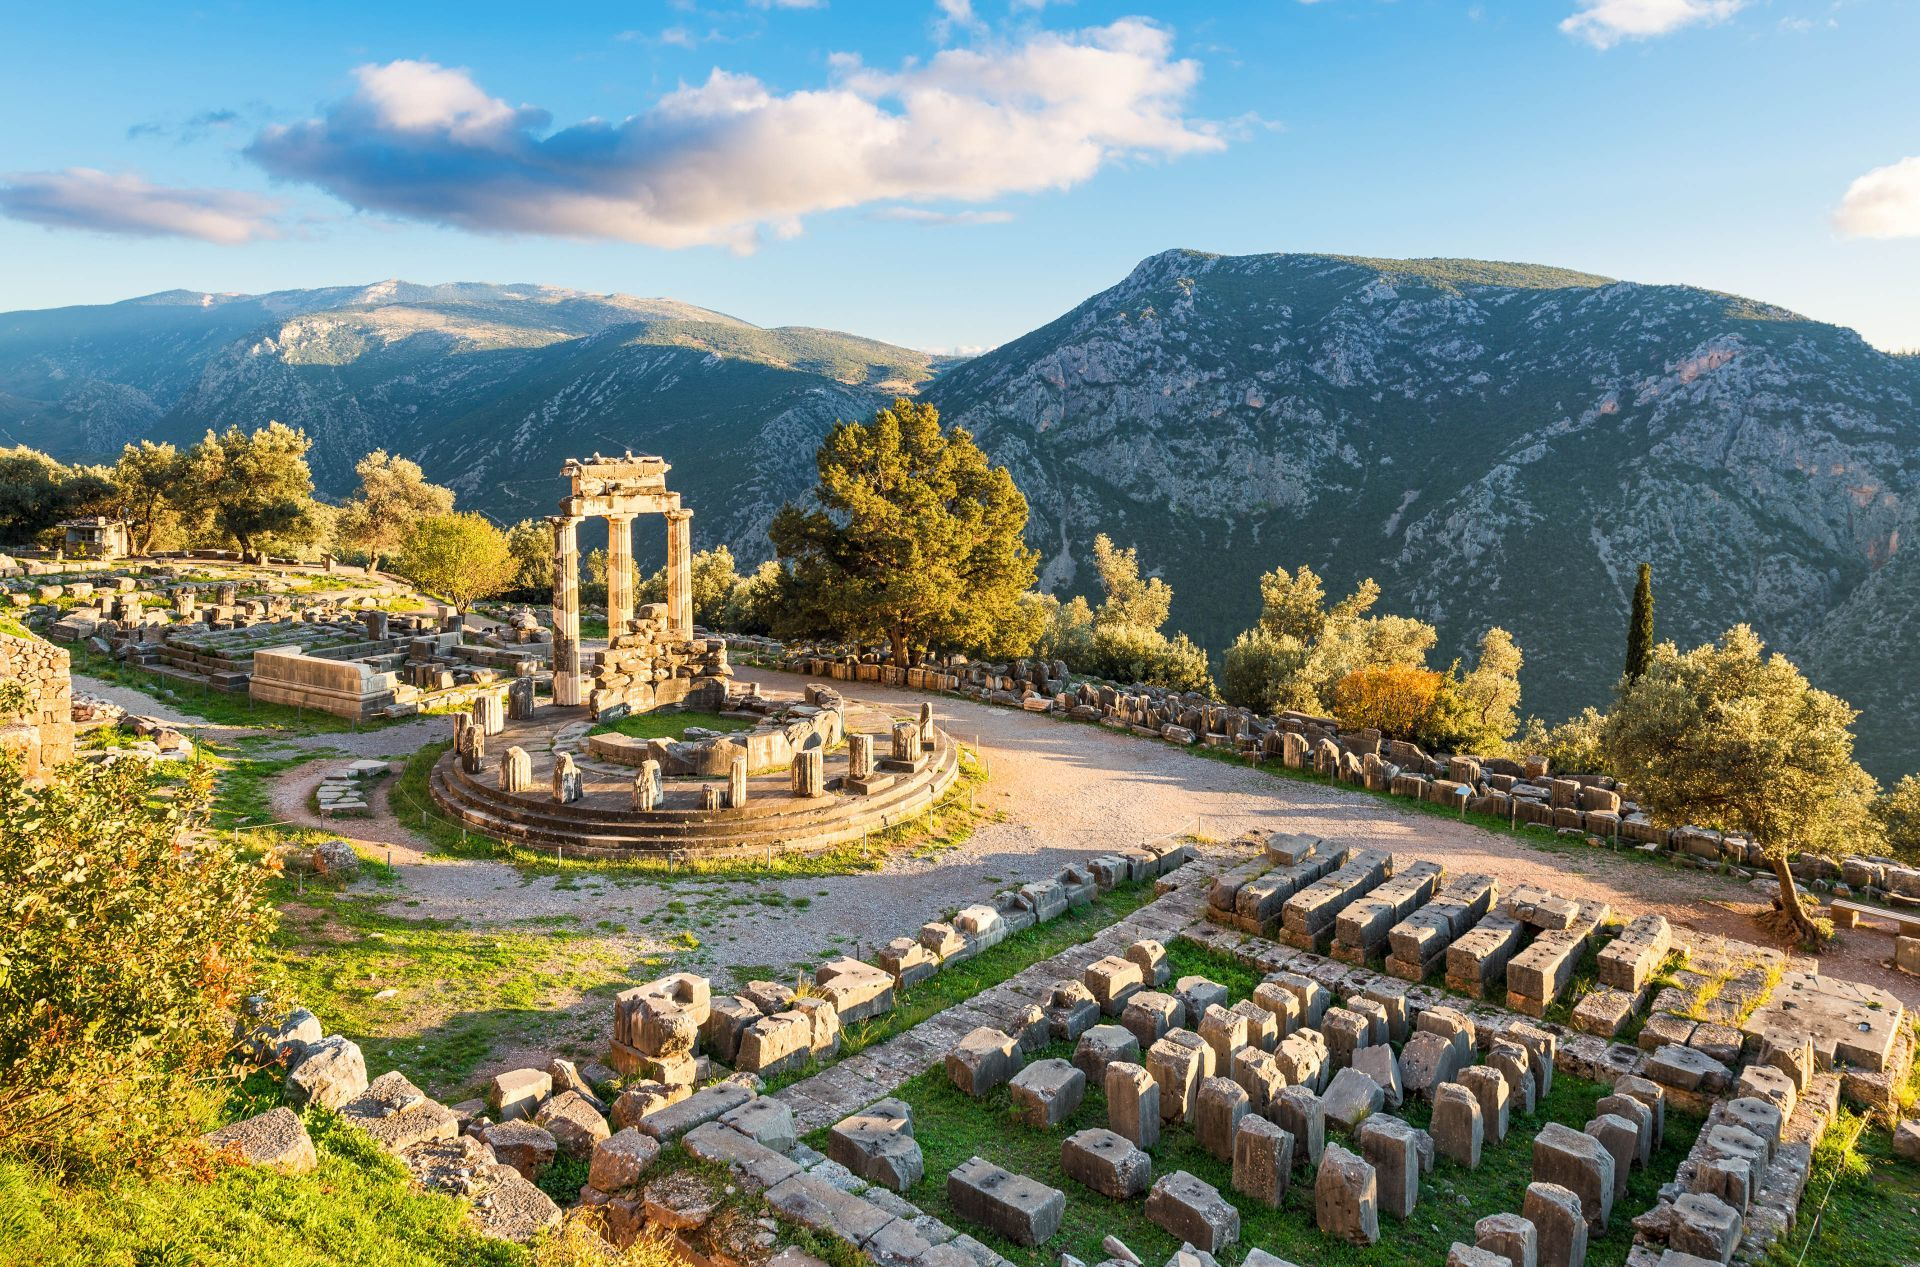How did this place influence ancient Greek culture? Delphi had a profound influence on ancient Greek culture primarily through the Oracle of Delphi, housed within the Temple of Apollo. Leaders, philosophers, and citizens from across the Greek world visited this site seeking guidance from the Pythia, the priestess of Apollo who delivered oracles. The decisions and strategies shaped by her prophecies influenced political and social dynamics throughout the ancient Greek city-states. Moreover, Delphi was also the site of the Pythian Games, similar in prestige to the Olympic Games, which further consolidated its cultural significance. What are the Pythian Games? The Pythian Games were one of the four Panhellenic Games of ancient Greece, and they were held in Delphi every four years in honor of Apollo. They included not only athletic contests but also musical and theatrical competitions, reflecting the significance of arts in Greek culture. These games helped foster unity and peaceful relations among the various Greek city-states under the religious and cultural banner of Apollo's sanctuary. 